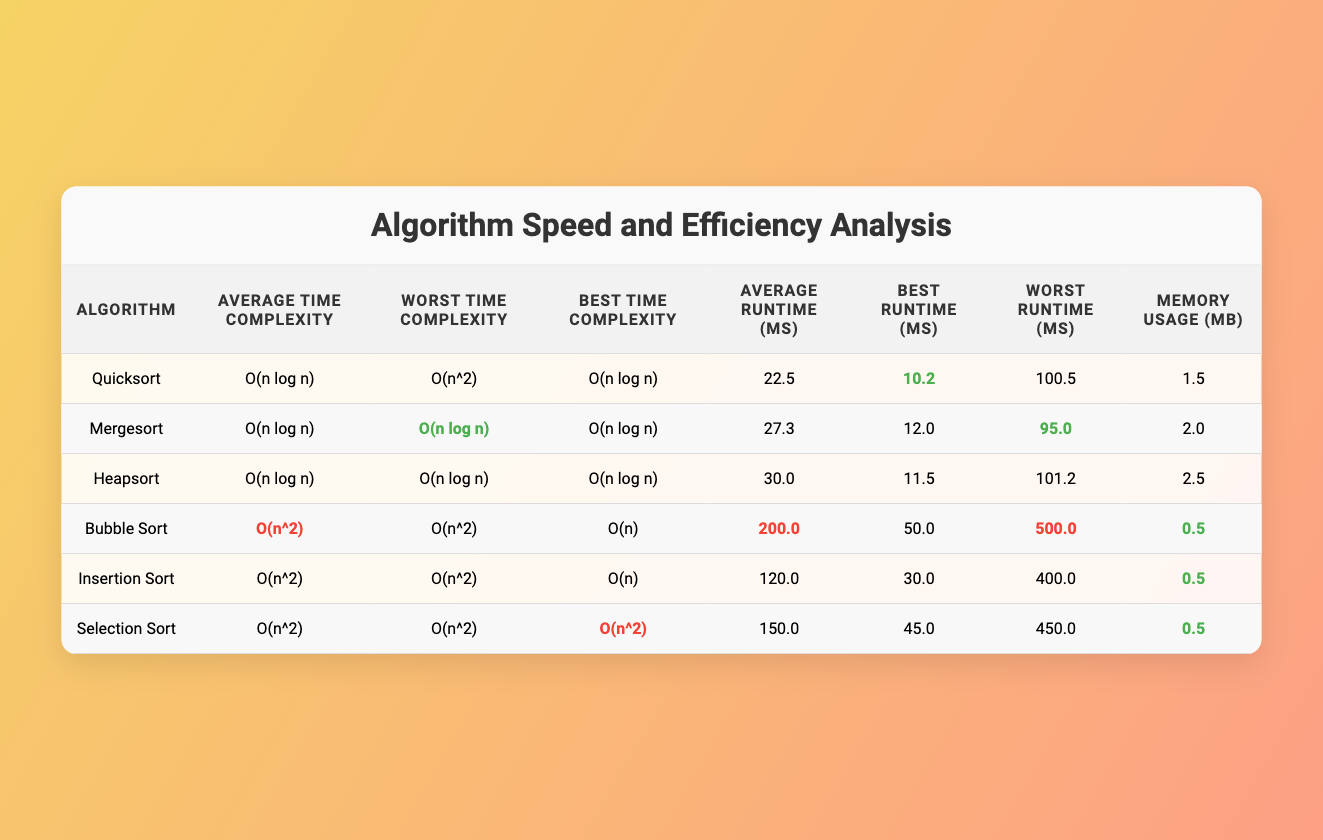What is the best case runtime for Quicksort? The table shows "Best Runtime (ms)" for Quicksort as 10.2, located in the row corresponding to the Quicksort algorithm.
Answer: 10.2 ms Which algorithm has the highest average case runtime? Looking at the "Average Runtime (ms)" column, Bubble Sort has the highest value at 200.0 ms.
Answer: Bubble Sort Does Mergesort have a worse time complexity than Bubble Sort? By comparing the "Worst Time Complexity" values, Mergesort has O(n log n) while Bubble Sort has O(n^2), making Mergesort more efficient in the worst case.
Answer: No Calculate the difference in memory usage between Heapsort and Quicksort. Heapsort uses 2.5 MB and Quicksort uses 1.5 MB, so 2.5 - 1.5 = 1.0 MB difference in memory usage.
Answer: 1.0 MB What is the average runtime in milliseconds of the algorithms with quadratic time complexity? The average runtimes for Bubble Sort, Insertion Sort, and Selection Sort are 200.0, 120.0, and 150.0 ms respectively, so calculating (200 + 120 + 150) / 3 yields an average of 156.67 ms.
Answer: 156.67 ms Which algorithm has the lowest best case runtime? Checking the "Best Runtime (ms)" column shows that Insertion Sort has the lowest value at 30.0 ms.
Answer: Insertion Sort Are all algorithms with the same average time complexity having the same worst case complexity? By examining the "Average Time Complexity" and "Worst Time Complexity" columns, only Quicksort has a worse case of O(n^2), while the others have O(n log n) despite having O(n log n) average complexity.
Answer: No What is the total memory usage of all algorithms in MB? By adding all the memory usages: 1.5 + 2.0 + 2.5 + 0.5 + 0.5 + 0.5 = 7.5 MB total memory usage across all algorithms.
Answer: 7.5 MB Identify the algorithm with the best average case runtime and explain its significance. Quicksort has an average case runtime of 22.5 ms, which is the best among the algorithms listed. This is significant as it indicates efficiency in typical scenarios.
Answer: Quicksort Which algorithm has the highest worst case runtime? Looking at the "Worst Runtime (ms)" column, Bubble Sort has the highest value at 500.0 ms, making it the least efficient in its worst case.
Answer: Bubble Sort 